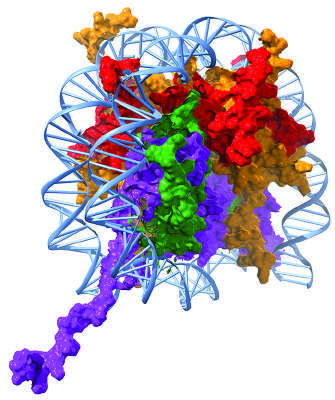how are the histone subunits charged?
Answer the question using a single word or phrase. Positively charged 